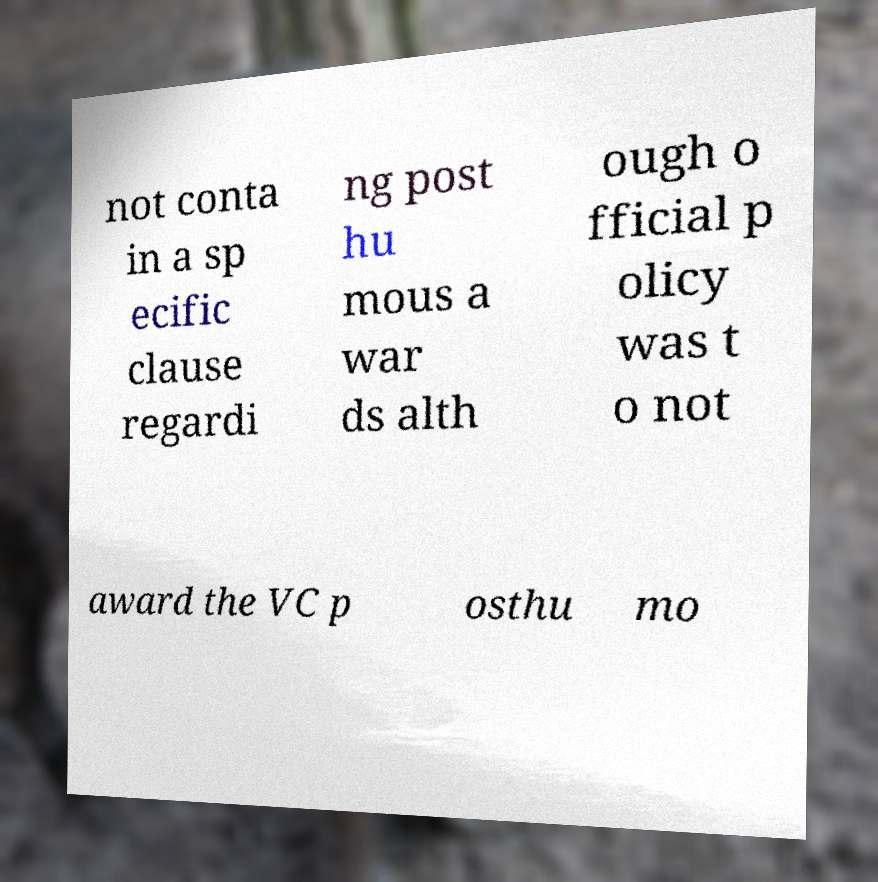Could you assist in decoding the text presented in this image and type it out clearly? not conta in a sp ecific clause regardi ng post hu mous a war ds alth ough o fficial p olicy was t o not award the VC p osthu mo 